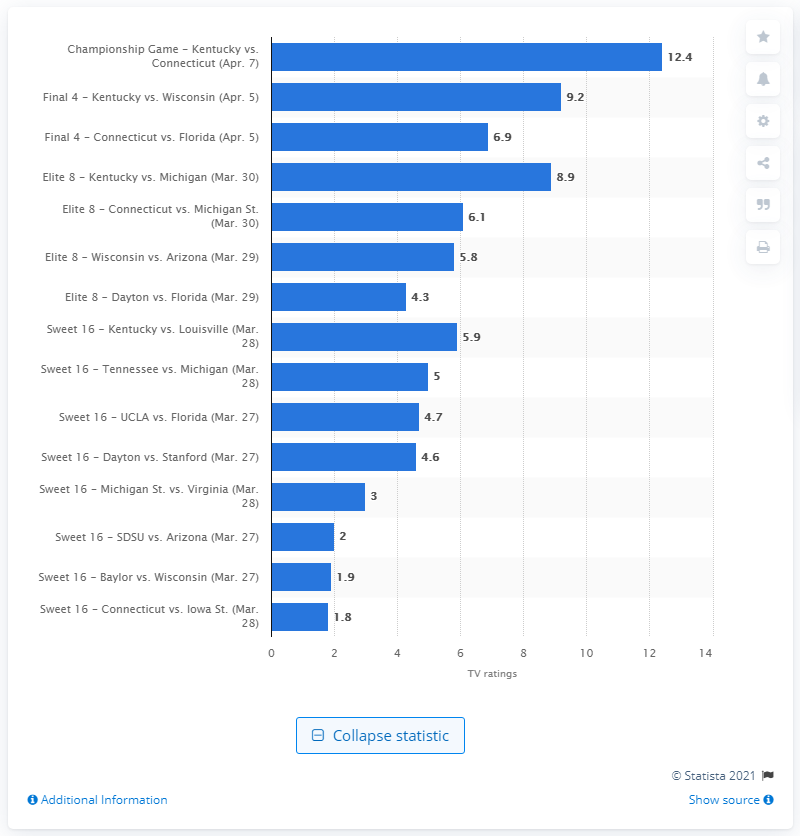Draw attention to some important aspects in this diagram. The championship game between Connecticut and Kentucky had a rating of 12.4. 